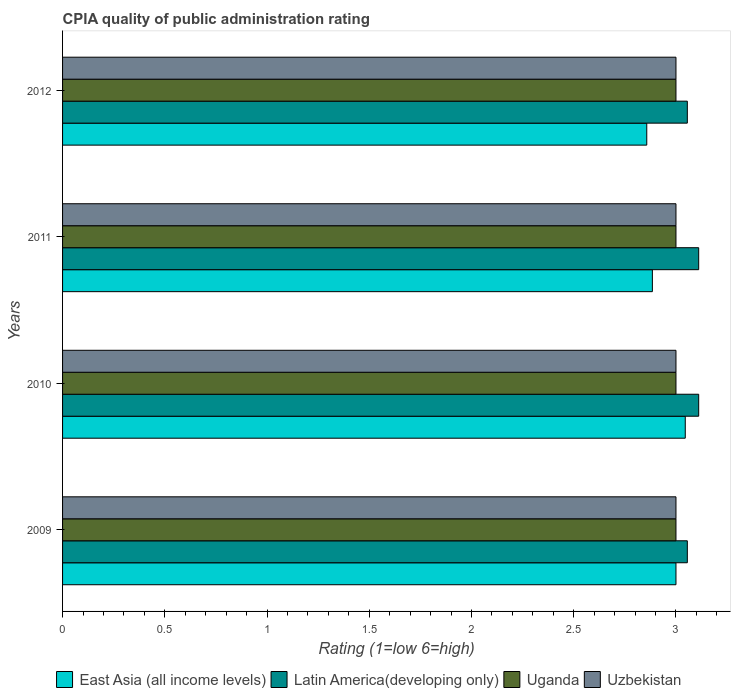How many different coloured bars are there?
Provide a succinct answer. 4. How many groups of bars are there?
Provide a succinct answer. 4. Are the number of bars per tick equal to the number of legend labels?
Ensure brevity in your answer.  Yes. Across all years, what is the maximum CPIA rating in Uzbekistan?
Your answer should be very brief. 3. Across all years, what is the minimum CPIA rating in Uzbekistan?
Make the answer very short. 3. What is the total CPIA rating in Latin America(developing only) in the graph?
Offer a terse response. 12.33. What is the difference between the CPIA rating in Uzbekistan in 2010 and the CPIA rating in Latin America(developing only) in 2012?
Ensure brevity in your answer.  -0.06. What is the average CPIA rating in East Asia (all income levels) per year?
Your response must be concise. 2.95. In the year 2010, what is the difference between the CPIA rating in East Asia (all income levels) and CPIA rating in Latin America(developing only)?
Keep it short and to the point. -0.07. What is the ratio of the CPIA rating in Uzbekistan in 2011 to that in 2012?
Offer a very short reply. 1. What is the difference between the highest and the second highest CPIA rating in Latin America(developing only)?
Keep it short and to the point. 0. In how many years, is the CPIA rating in East Asia (all income levels) greater than the average CPIA rating in East Asia (all income levels) taken over all years?
Your answer should be compact. 2. What does the 1st bar from the top in 2009 represents?
Give a very brief answer. Uzbekistan. What does the 3rd bar from the bottom in 2010 represents?
Give a very brief answer. Uganda. Are all the bars in the graph horizontal?
Provide a short and direct response. Yes. How many years are there in the graph?
Provide a succinct answer. 4. Are the values on the major ticks of X-axis written in scientific E-notation?
Your response must be concise. No. Does the graph contain any zero values?
Keep it short and to the point. No. Where does the legend appear in the graph?
Your response must be concise. Bottom center. What is the title of the graph?
Offer a very short reply. CPIA quality of public administration rating. What is the label or title of the X-axis?
Provide a succinct answer. Rating (1=low 6=high). What is the Rating (1=low 6=high) in East Asia (all income levels) in 2009?
Your response must be concise. 3. What is the Rating (1=low 6=high) in Latin America(developing only) in 2009?
Provide a succinct answer. 3.06. What is the Rating (1=low 6=high) in Uganda in 2009?
Provide a succinct answer. 3. What is the Rating (1=low 6=high) in East Asia (all income levels) in 2010?
Offer a very short reply. 3.05. What is the Rating (1=low 6=high) in Latin America(developing only) in 2010?
Give a very brief answer. 3.11. What is the Rating (1=low 6=high) of Uzbekistan in 2010?
Make the answer very short. 3. What is the Rating (1=low 6=high) in East Asia (all income levels) in 2011?
Provide a succinct answer. 2.88. What is the Rating (1=low 6=high) of Latin America(developing only) in 2011?
Make the answer very short. 3.11. What is the Rating (1=low 6=high) of East Asia (all income levels) in 2012?
Your response must be concise. 2.86. What is the Rating (1=low 6=high) of Latin America(developing only) in 2012?
Offer a terse response. 3.06. Across all years, what is the maximum Rating (1=low 6=high) of East Asia (all income levels)?
Your response must be concise. 3.05. Across all years, what is the maximum Rating (1=low 6=high) in Latin America(developing only)?
Provide a succinct answer. 3.11. Across all years, what is the minimum Rating (1=low 6=high) of East Asia (all income levels)?
Offer a very short reply. 2.86. Across all years, what is the minimum Rating (1=low 6=high) in Latin America(developing only)?
Offer a terse response. 3.06. Across all years, what is the minimum Rating (1=low 6=high) in Uganda?
Your answer should be very brief. 3. What is the total Rating (1=low 6=high) of East Asia (all income levels) in the graph?
Offer a very short reply. 11.79. What is the total Rating (1=low 6=high) in Latin America(developing only) in the graph?
Offer a very short reply. 12.33. What is the total Rating (1=low 6=high) in Uganda in the graph?
Provide a succinct answer. 12. What is the difference between the Rating (1=low 6=high) in East Asia (all income levels) in 2009 and that in 2010?
Keep it short and to the point. -0.05. What is the difference between the Rating (1=low 6=high) in Latin America(developing only) in 2009 and that in 2010?
Offer a very short reply. -0.06. What is the difference between the Rating (1=low 6=high) of Uganda in 2009 and that in 2010?
Ensure brevity in your answer.  0. What is the difference between the Rating (1=low 6=high) in East Asia (all income levels) in 2009 and that in 2011?
Provide a short and direct response. 0.12. What is the difference between the Rating (1=low 6=high) of Latin America(developing only) in 2009 and that in 2011?
Ensure brevity in your answer.  -0.06. What is the difference between the Rating (1=low 6=high) in Uzbekistan in 2009 and that in 2011?
Provide a succinct answer. 0. What is the difference between the Rating (1=low 6=high) in East Asia (all income levels) in 2009 and that in 2012?
Your answer should be compact. 0.14. What is the difference between the Rating (1=low 6=high) of Uganda in 2009 and that in 2012?
Ensure brevity in your answer.  0. What is the difference between the Rating (1=low 6=high) of Uzbekistan in 2009 and that in 2012?
Give a very brief answer. 0. What is the difference between the Rating (1=low 6=high) in East Asia (all income levels) in 2010 and that in 2011?
Give a very brief answer. 0.16. What is the difference between the Rating (1=low 6=high) in East Asia (all income levels) in 2010 and that in 2012?
Provide a short and direct response. 0.19. What is the difference between the Rating (1=low 6=high) in Latin America(developing only) in 2010 and that in 2012?
Give a very brief answer. 0.06. What is the difference between the Rating (1=low 6=high) in Uganda in 2010 and that in 2012?
Give a very brief answer. 0. What is the difference between the Rating (1=low 6=high) in East Asia (all income levels) in 2011 and that in 2012?
Your response must be concise. 0.03. What is the difference between the Rating (1=low 6=high) in Latin America(developing only) in 2011 and that in 2012?
Your response must be concise. 0.06. What is the difference between the Rating (1=low 6=high) of Uzbekistan in 2011 and that in 2012?
Ensure brevity in your answer.  0. What is the difference between the Rating (1=low 6=high) of East Asia (all income levels) in 2009 and the Rating (1=low 6=high) of Latin America(developing only) in 2010?
Make the answer very short. -0.11. What is the difference between the Rating (1=low 6=high) in Latin America(developing only) in 2009 and the Rating (1=low 6=high) in Uganda in 2010?
Make the answer very short. 0.06. What is the difference between the Rating (1=low 6=high) in Latin America(developing only) in 2009 and the Rating (1=low 6=high) in Uzbekistan in 2010?
Provide a short and direct response. 0.06. What is the difference between the Rating (1=low 6=high) of Uganda in 2009 and the Rating (1=low 6=high) of Uzbekistan in 2010?
Keep it short and to the point. 0. What is the difference between the Rating (1=low 6=high) in East Asia (all income levels) in 2009 and the Rating (1=low 6=high) in Latin America(developing only) in 2011?
Offer a terse response. -0.11. What is the difference between the Rating (1=low 6=high) in East Asia (all income levels) in 2009 and the Rating (1=low 6=high) in Uganda in 2011?
Your response must be concise. 0. What is the difference between the Rating (1=low 6=high) of Latin America(developing only) in 2009 and the Rating (1=low 6=high) of Uganda in 2011?
Provide a short and direct response. 0.06. What is the difference between the Rating (1=low 6=high) of Latin America(developing only) in 2009 and the Rating (1=low 6=high) of Uzbekistan in 2011?
Provide a succinct answer. 0.06. What is the difference between the Rating (1=low 6=high) in Uganda in 2009 and the Rating (1=low 6=high) in Uzbekistan in 2011?
Ensure brevity in your answer.  0. What is the difference between the Rating (1=low 6=high) in East Asia (all income levels) in 2009 and the Rating (1=low 6=high) in Latin America(developing only) in 2012?
Provide a short and direct response. -0.06. What is the difference between the Rating (1=low 6=high) of Latin America(developing only) in 2009 and the Rating (1=low 6=high) of Uganda in 2012?
Keep it short and to the point. 0.06. What is the difference between the Rating (1=low 6=high) in Latin America(developing only) in 2009 and the Rating (1=low 6=high) in Uzbekistan in 2012?
Give a very brief answer. 0.06. What is the difference between the Rating (1=low 6=high) in East Asia (all income levels) in 2010 and the Rating (1=low 6=high) in Latin America(developing only) in 2011?
Ensure brevity in your answer.  -0.07. What is the difference between the Rating (1=low 6=high) of East Asia (all income levels) in 2010 and the Rating (1=low 6=high) of Uganda in 2011?
Give a very brief answer. 0.05. What is the difference between the Rating (1=low 6=high) in East Asia (all income levels) in 2010 and the Rating (1=low 6=high) in Uzbekistan in 2011?
Give a very brief answer. 0.05. What is the difference between the Rating (1=low 6=high) of Latin America(developing only) in 2010 and the Rating (1=low 6=high) of Uzbekistan in 2011?
Give a very brief answer. 0.11. What is the difference between the Rating (1=low 6=high) of East Asia (all income levels) in 2010 and the Rating (1=low 6=high) of Latin America(developing only) in 2012?
Provide a succinct answer. -0.01. What is the difference between the Rating (1=low 6=high) of East Asia (all income levels) in 2010 and the Rating (1=low 6=high) of Uganda in 2012?
Offer a terse response. 0.05. What is the difference between the Rating (1=low 6=high) of East Asia (all income levels) in 2010 and the Rating (1=low 6=high) of Uzbekistan in 2012?
Offer a very short reply. 0.05. What is the difference between the Rating (1=low 6=high) in Latin America(developing only) in 2010 and the Rating (1=low 6=high) in Uganda in 2012?
Give a very brief answer. 0.11. What is the difference between the Rating (1=low 6=high) in East Asia (all income levels) in 2011 and the Rating (1=low 6=high) in Latin America(developing only) in 2012?
Ensure brevity in your answer.  -0.17. What is the difference between the Rating (1=low 6=high) of East Asia (all income levels) in 2011 and the Rating (1=low 6=high) of Uganda in 2012?
Keep it short and to the point. -0.12. What is the difference between the Rating (1=low 6=high) in East Asia (all income levels) in 2011 and the Rating (1=low 6=high) in Uzbekistan in 2012?
Offer a terse response. -0.12. What is the difference between the Rating (1=low 6=high) in Latin America(developing only) in 2011 and the Rating (1=low 6=high) in Uganda in 2012?
Ensure brevity in your answer.  0.11. What is the difference between the Rating (1=low 6=high) of Latin America(developing only) in 2011 and the Rating (1=low 6=high) of Uzbekistan in 2012?
Provide a short and direct response. 0.11. What is the average Rating (1=low 6=high) in East Asia (all income levels) per year?
Offer a very short reply. 2.95. What is the average Rating (1=low 6=high) of Latin America(developing only) per year?
Offer a very short reply. 3.08. In the year 2009, what is the difference between the Rating (1=low 6=high) of East Asia (all income levels) and Rating (1=low 6=high) of Latin America(developing only)?
Offer a terse response. -0.06. In the year 2009, what is the difference between the Rating (1=low 6=high) in East Asia (all income levels) and Rating (1=low 6=high) in Uganda?
Your answer should be very brief. 0. In the year 2009, what is the difference between the Rating (1=low 6=high) in East Asia (all income levels) and Rating (1=low 6=high) in Uzbekistan?
Provide a short and direct response. 0. In the year 2009, what is the difference between the Rating (1=low 6=high) of Latin America(developing only) and Rating (1=low 6=high) of Uganda?
Your response must be concise. 0.06. In the year 2009, what is the difference between the Rating (1=low 6=high) in Latin America(developing only) and Rating (1=low 6=high) in Uzbekistan?
Make the answer very short. 0.06. In the year 2010, what is the difference between the Rating (1=low 6=high) of East Asia (all income levels) and Rating (1=low 6=high) of Latin America(developing only)?
Your answer should be compact. -0.07. In the year 2010, what is the difference between the Rating (1=low 6=high) of East Asia (all income levels) and Rating (1=low 6=high) of Uganda?
Keep it short and to the point. 0.05. In the year 2010, what is the difference between the Rating (1=low 6=high) in East Asia (all income levels) and Rating (1=low 6=high) in Uzbekistan?
Keep it short and to the point. 0.05. In the year 2010, what is the difference between the Rating (1=low 6=high) of Latin America(developing only) and Rating (1=low 6=high) of Uganda?
Keep it short and to the point. 0.11. In the year 2010, what is the difference between the Rating (1=low 6=high) in Latin America(developing only) and Rating (1=low 6=high) in Uzbekistan?
Offer a very short reply. 0.11. In the year 2010, what is the difference between the Rating (1=low 6=high) in Uganda and Rating (1=low 6=high) in Uzbekistan?
Offer a terse response. 0. In the year 2011, what is the difference between the Rating (1=low 6=high) in East Asia (all income levels) and Rating (1=low 6=high) in Latin America(developing only)?
Ensure brevity in your answer.  -0.23. In the year 2011, what is the difference between the Rating (1=low 6=high) of East Asia (all income levels) and Rating (1=low 6=high) of Uganda?
Keep it short and to the point. -0.12. In the year 2011, what is the difference between the Rating (1=low 6=high) in East Asia (all income levels) and Rating (1=low 6=high) in Uzbekistan?
Make the answer very short. -0.12. In the year 2011, what is the difference between the Rating (1=low 6=high) of Latin America(developing only) and Rating (1=low 6=high) of Uzbekistan?
Your answer should be very brief. 0.11. In the year 2011, what is the difference between the Rating (1=low 6=high) of Uganda and Rating (1=low 6=high) of Uzbekistan?
Your response must be concise. 0. In the year 2012, what is the difference between the Rating (1=low 6=high) in East Asia (all income levels) and Rating (1=low 6=high) in Latin America(developing only)?
Keep it short and to the point. -0.2. In the year 2012, what is the difference between the Rating (1=low 6=high) of East Asia (all income levels) and Rating (1=low 6=high) of Uganda?
Your response must be concise. -0.14. In the year 2012, what is the difference between the Rating (1=low 6=high) in East Asia (all income levels) and Rating (1=low 6=high) in Uzbekistan?
Offer a very short reply. -0.14. In the year 2012, what is the difference between the Rating (1=low 6=high) of Latin America(developing only) and Rating (1=low 6=high) of Uganda?
Your response must be concise. 0.06. In the year 2012, what is the difference between the Rating (1=low 6=high) of Latin America(developing only) and Rating (1=low 6=high) of Uzbekistan?
Offer a very short reply. 0.06. In the year 2012, what is the difference between the Rating (1=low 6=high) of Uganda and Rating (1=low 6=high) of Uzbekistan?
Ensure brevity in your answer.  0. What is the ratio of the Rating (1=low 6=high) in East Asia (all income levels) in 2009 to that in 2010?
Provide a short and direct response. 0.99. What is the ratio of the Rating (1=low 6=high) of Latin America(developing only) in 2009 to that in 2010?
Offer a terse response. 0.98. What is the ratio of the Rating (1=low 6=high) of Uganda in 2009 to that in 2010?
Your answer should be very brief. 1. What is the ratio of the Rating (1=low 6=high) of East Asia (all income levels) in 2009 to that in 2011?
Your response must be concise. 1.04. What is the ratio of the Rating (1=low 6=high) of Latin America(developing only) in 2009 to that in 2011?
Your response must be concise. 0.98. What is the ratio of the Rating (1=low 6=high) in Uganda in 2009 to that in 2012?
Keep it short and to the point. 1. What is the ratio of the Rating (1=low 6=high) of East Asia (all income levels) in 2010 to that in 2011?
Your answer should be very brief. 1.06. What is the ratio of the Rating (1=low 6=high) of Latin America(developing only) in 2010 to that in 2011?
Ensure brevity in your answer.  1. What is the ratio of the Rating (1=low 6=high) in Uzbekistan in 2010 to that in 2011?
Provide a succinct answer. 1. What is the ratio of the Rating (1=low 6=high) of East Asia (all income levels) in 2010 to that in 2012?
Provide a short and direct response. 1.07. What is the ratio of the Rating (1=low 6=high) in Latin America(developing only) in 2010 to that in 2012?
Give a very brief answer. 1.02. What is the ratio of the Rating (1=low 6=high) in East Asia (all income levels) in 2011 to that in 2012?
Provide a succinct answer. 1.01. What is the ratio of the Rating (1=low 6=high) in Latin America(developing only) in 2011 to that in 2012?
Provide a succinct answer. 1.02. What is the difference between the highest and the second highest Rating (1=low 6=high) in East Asia (all income levels)?
Offer a very short reply. 0.05. What is the difference between the highest and the second highest Rating (1=low 6=high) of Latin America(developing only)?
Give a very brief answer. 0. What is the difference between the highest and the lowest Rating (1=low 6=high) of East Asia (all income levels)?
Your answer should be compact. 0.19. What is the difference between the highest and the lowest Rating (1=low 6=high) of Latin America(developing only)?
Provide a succinct answer. 0.06. 